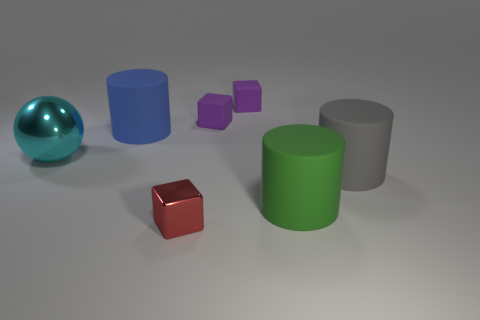How many different colors are present among the objects, and could you name them? There are five distinct colors among the objects in the image. These colors are teal for the reflective sphere, blue and green for the two cylinders, and purple and brown for the cubes. Additionally, there is a red cube which introduces the sixth color in the scene. 